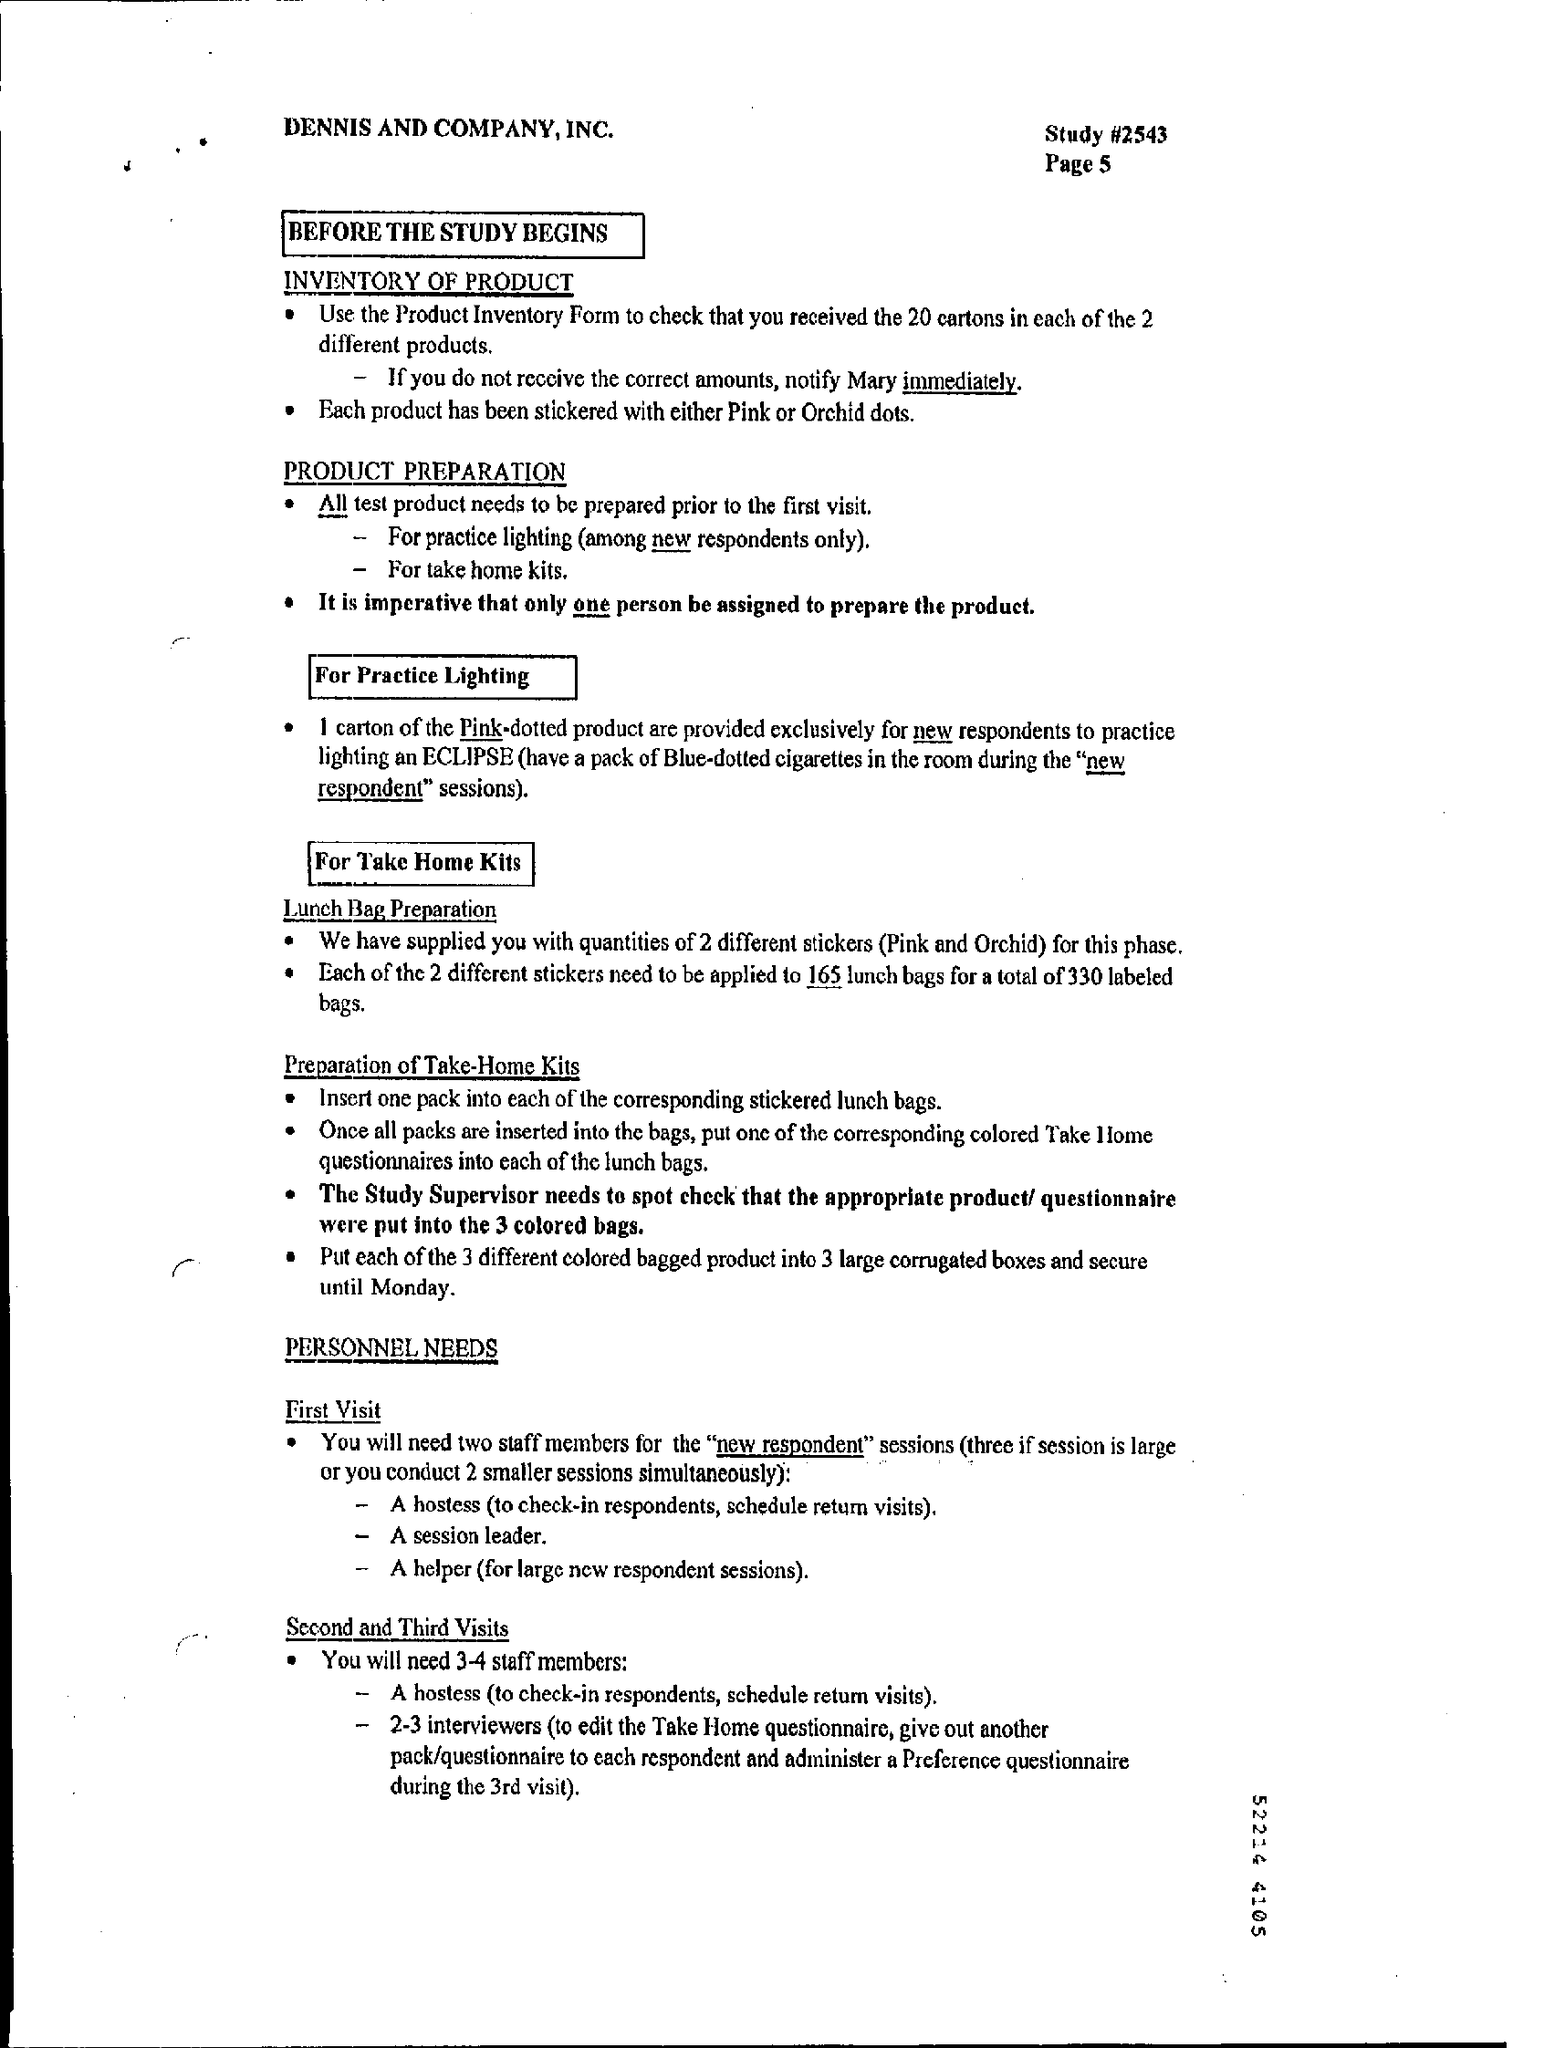Identify some key points in this picture. It is recommended that one person be assigned to prepare the product. The study number is #2543. It is necessary for the Study Supervisor to conduct a spot check to ensure that the appropriate product/questionnaire were placed in the correctly colored bags. 